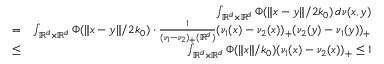Convert formula to latex. <formula><loc_0><loc_0><loc_500><loc_500>\begin{array} { r l r } & { \int _ { \mathbb { R } ^ { d } \times \mathbb { R } ^ { d } } \Phi ( \| x - y \| / 2 k _ { 0 } ) \, d \nu ( x , y ) } \\ & { = } & { \int _ { \mathbb { R } ^ { d } \times \mathbb { R } ^ { d } } \Phi ( \| x - y \| / 2 k _ { 0 } ) \cdot \frac { 1 } { ( \nu _ { 1 } - \nu _ { 2 } ) _ { + } ( \mathbb { R } ^ { d } ) } ( \nu _ { 1 } ( x ) - \nu _ { 2 } ( x ) ) _ { + } ( \nu _ { 2 } ( y ) - \nu _ { 1 } ( y ) ) _ { + } } \\ & { \leq } & { \int _ { \mathbb { R } ^ { d } \times \mathbb { R } ^ { d } } \Phi ( \| x \| / k _ { 0 } ) ( \nu _ { 1 } ( x ) - \nu _ { 2 } ( x ) ) _ { + } \leq 1 } \end{array}</formula> 